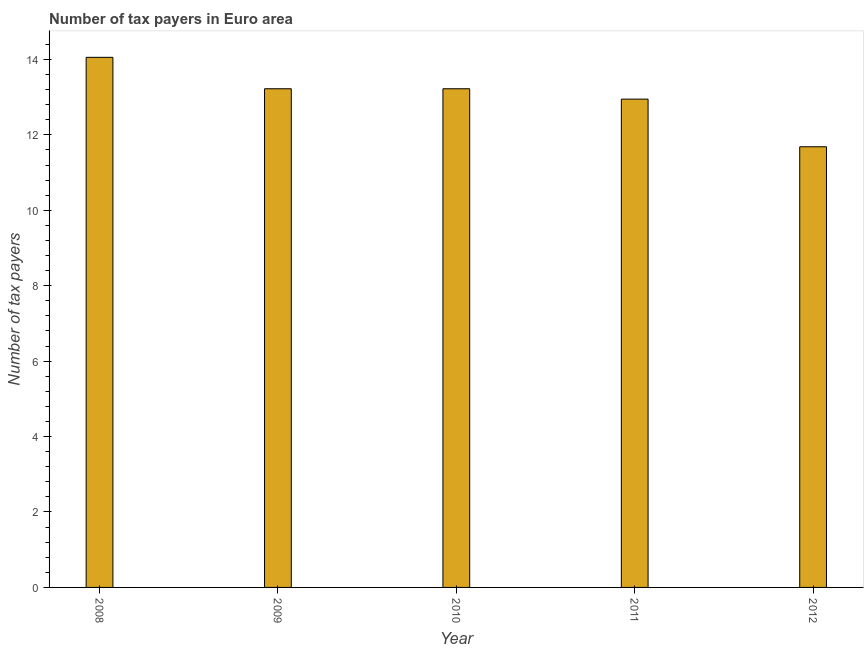Does the graph contain any zero values?
Offer a terse response. No. What is the title of the graph?
Provide a short and direct response. Number of tax payers in Euro area. What is the label or title of the X-axis?
Keep it short and to the point. Year. What is the label or title of the Y-axis?
Your answer should be compact. Number of tax payers. What is the number of tax payers in 2012?
Offer a very short reply. 11.68. Across all years, what is the maximum number of tax payers?
Give a very brief answer. 14.06. Across all years, what is the minimum number of tax payers?
Give a very brief answer. 11.68. What is the sum of the number of tax payers?
Provide a succinct answer. 65.13. What is the difference between the number of tax payers in 2010 and 2011?
Give a very brief answer. 0.28. What is the average number of tax payers per year?
Make the answer very short. 13.03. What is the median number of tax payers?
Ensure brevity in your answer.  13.22. Do a majority of the years between 2011 and 2012 (inclusive) have number of tax payers greater than 11.6 ?
Your answer should be compact. Yes. What is the ratio of the number of tax payers in 2008 to that in 2011?
Keep it short and to the point. 1.09. Is the difference between the number of tax payers in 2010 and 2012 greater than the difference between any two years?
Give a very brief answer. No. What is the difference between the highest and the second highest number of tax payers?
Provide a succinct answer. 0.83. Is the sum of the number of tax payers in 2008 and 2009 greater than the maximum number of tax payers across all years?
Provide a short and direct response. Yes. What is the difference between the highest and the lowest number of tax payers?
Provide a short and direct response. 2.37. In how many years, is the number of tax payers greater than the average number of tax payers taken over all years?
Your response must be concise. 3. What is the Number of tax payers of 2008?
Your response must be concise. 14.06. What is the Number of tax payers in 2009?
Offer a very short reply. 13.22. What is the Number of tax payers in 2010?
Give a very brief answer. 13.22. What is the Number of tax payers of 2011?
Give a very brief answer. 12.95. What is the Number of tax payers in 2012?
Offer a very short reply. 11.68. What is the difference between the Number of tax payers in 2008 and 2009?
Offer a terse response. 0.83. What is the difference between the Number of tax payers in 2008 and 2010?
Make the answer very short. 0.83. What is the difference between the Number of tax payers in 2008 and 2011?
Your answer should be very brief. 1.11. What is the difference between the Number of tax payers in 2008 and 2012?
Give a very brief answer. 2.37. What is the difference between the Number of tax payers in 2009 and 2010?
Offer a terse response. 0. What is the difference between the Number of tax payers in 2009 and 2011?
Ensure brevity in your answer.  0.27. What is the difference between the Number of tax payers in 2009 and 2012?
Keep it short and to the point. 1.54. What is the difference between the Number of tax payers in 2010 and 2011?
Ensure brevity in your answer.  0.27. What is the difference between the Number of tax payers in 2010 and 2012?
Provide a short and direct response. 1.54. What is the difference between the Number of tax payers in 2011 and 2012?
Offer a terse response. 1.26. What is the ratio of the Number of tax payers in 2008 to that in 2009?
Provide a short and direct response. 1.06. What is the ratio of the Number of tax payers in 2008 to that in 2010?
Your answer should be very brief. 1.06. What is the ratio of the Number of tax payers in 2008 to that in 2011?
Your answer should be compact. 1.09. What is the ratio of the Number of tax payers in 2008 to that in 2012?
Make the answer very short. 1.2. What is the ratio of the Number of tax payers in 2009 to that in 2010?
Your response must be concise. 1. What is the ratio of the Number of tax payers in 2009 to that in 2011?
Give a very brief answer. 1.02. What is the ratio of the Number of tax payers in 2009 to that in 2012?
Your response must be concise. 1.13. What is the ratio of the Number of tax payers in 2010 to that in 2011?
Ensure brevity in your answer.  1.02. What is the ratio of the Number of tax payers in 2010 to that in 2012?
Ensure brevity in your answer.  1.13. What is the ratio of the Number of tax payers in 2011 to that in 2012?
Your answer should be very brief. 1.11. 